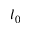<formula> <loc_0><loc_0><loc_500><loc_500>l _ { 0 }</formula> 